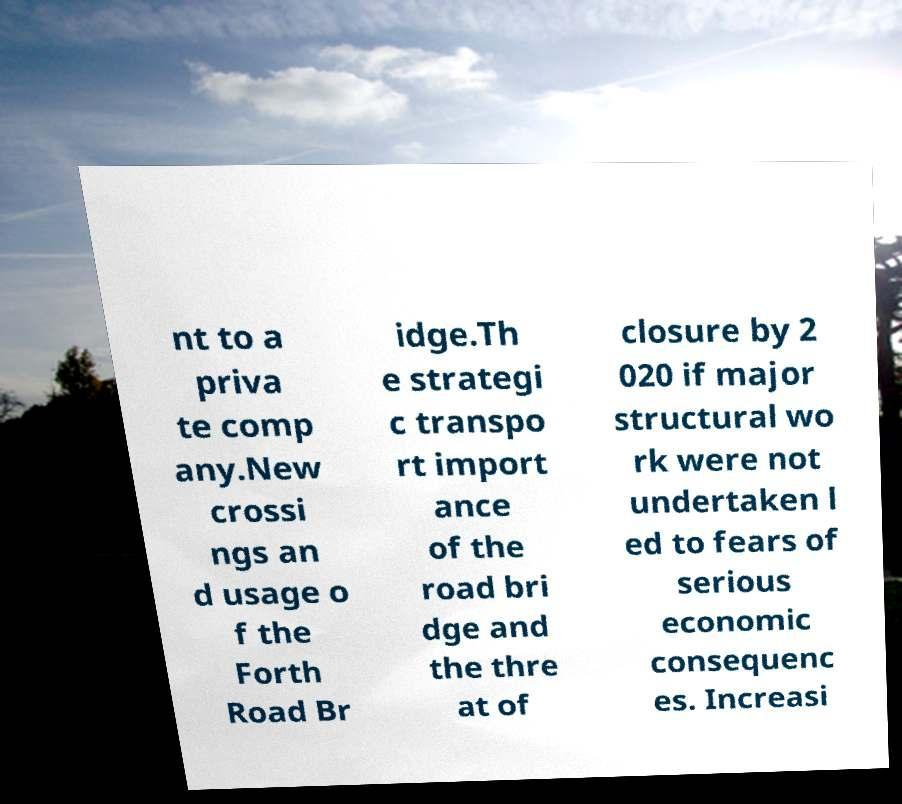There's text embedded in this image that I need extracted. Can you transcribe it verbatim? nt to a priva te comp any.New crossi ngs an d usage o f the Forth Road Br idge.Th e strategi c transpo rt import ance of the road bri dge and the thre at of closure by 2 020 if major structural wo rk were not undertaken l ed to fears of serious economic consequenc es. Increasi 